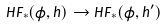Convert formula to latex. <formula><loc_0><loc_0><loc_500><loc_500>H F _ { \ast } ( \phi , h ) \to H F _ { \ast } ( \phi , h ^ { \prime } )</formula> 